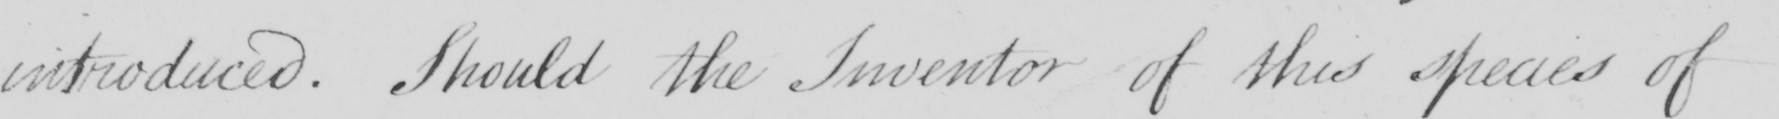Can you tell me what this handwritten text says? introduced . Should the Inventor of this species of 